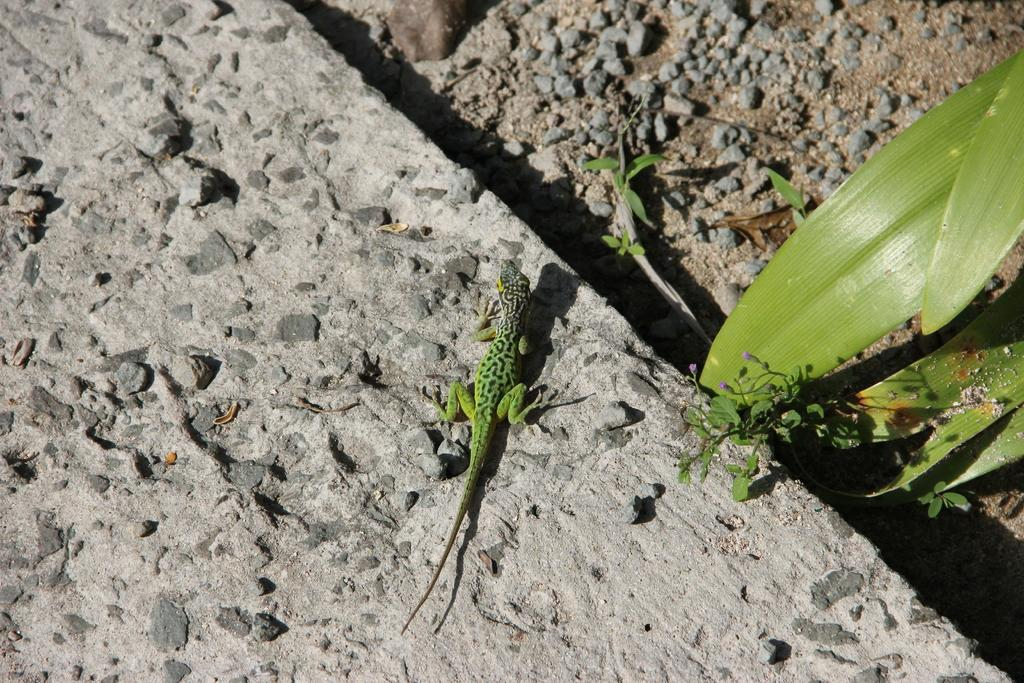What type of animal is on the wall in the image? There is a lizard on the wall in the image. What can be seen on the ground in the image? There are stones on the ground in the image. What type of vegetation is present in the image? There are leaves in the image. How many servants are present in the image? There are no servants present in the image. What type of plantation can be seen in the image? There is no plantation present in the image. 